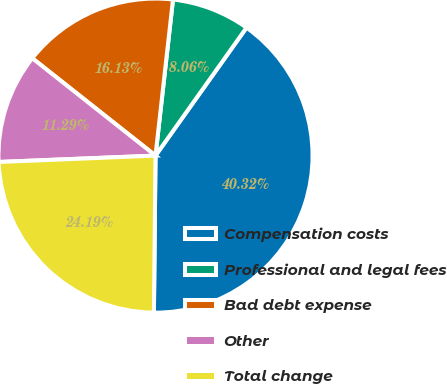Convert chart to OTSL. <chart><loc_0><loc_0><loc_500><loc_500><pie_chart><fcel>Compensation costs<fcel>Professional and legal fees<fcel>Bad debt expense<fcel>Other<fcel>Total change<nl><fcel>40.32%<fcel>8.06%<fcel>16.13%<fcel>11.29%<fcel>24.19%<nl></chart> 